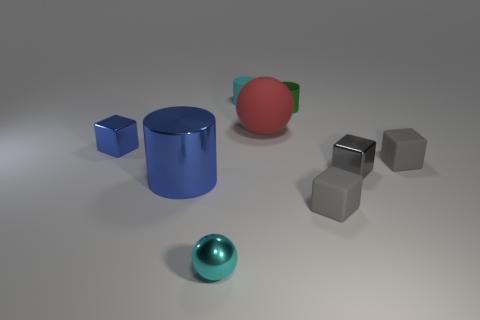Subtract all blue cylinders. Subtract all purple spheres. How many cylinders are left? 2 Subtract all yellow cubes. How many red spheres are left? 1 Add 4 tiny blues. How many things exist? 0 Subtract all gray things. Subtract all large blue cylinders. How many objects are left? 5 Add 4 big metal cylinders. How many big metal cylinders are left? 5 Add 6 green objects. How many green objects exist? 7 Add 1 small matte cylinders. How many objects exist? 10 Subtract all red balls. How many balls are left? 1 Subtract all tiny gray cubes. How many cubes are left? 1 Subtract 0 blue balls. How many objects are left? 9 